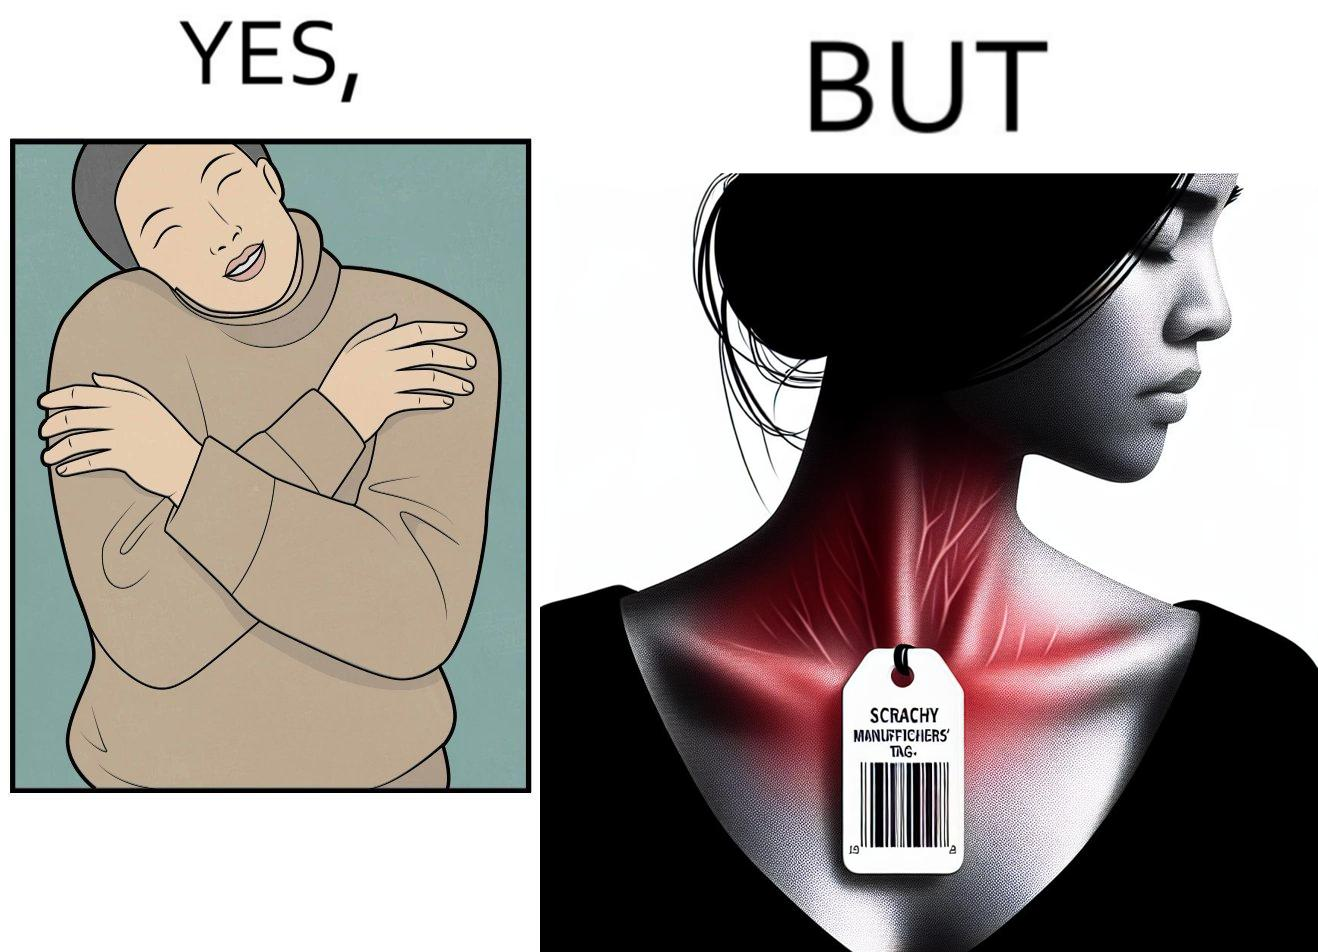Describe the content of this image. The images are funny since it shows how even though sweaters and other clothings provide much comfort, a tiny manufacturers tag ends up causing the user a lot of discomfort due to constant scratching 